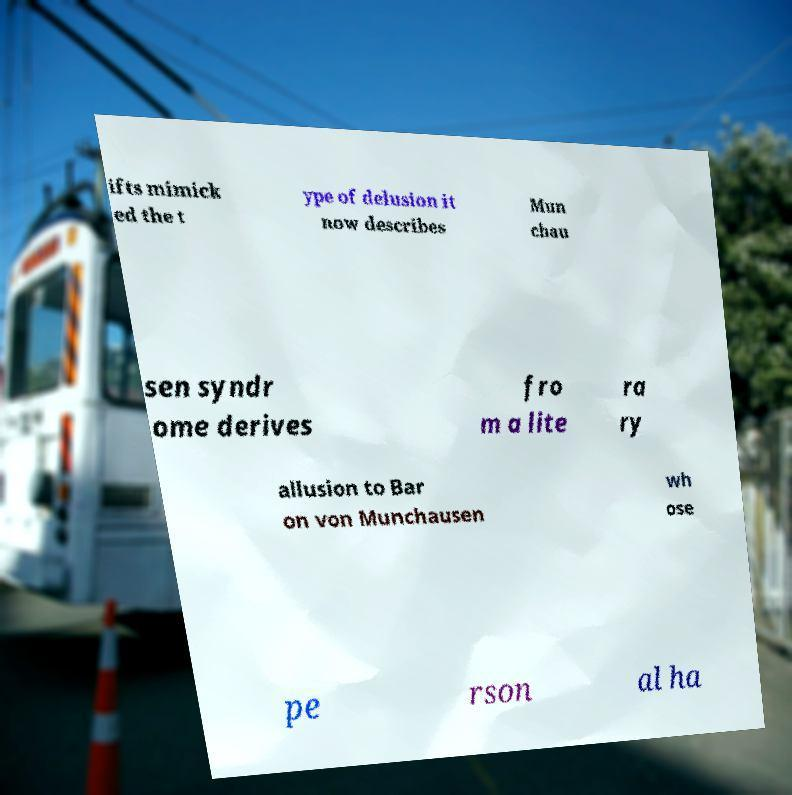Please read and relay the text visible in this image. What does it say? ifts mimick ed the t ype of delusion it now describes Mun chau sen syndr ome derives fro m a lite ra ry allusion to Bar on von Munchausen wh ose pe rson al ha 